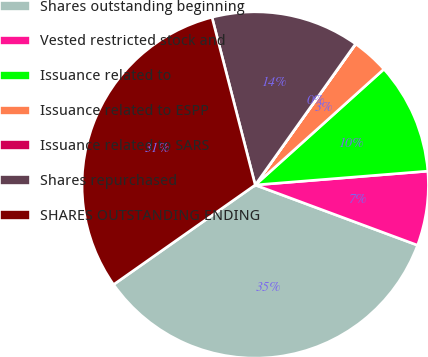Convert chart to OTSL. <chart><loc_0><loc_0><loc_500><loc_500><pie_chart><fcel>Shares outstanding beginning<fcel>Vested restricted stock and<fcel>Issuance related to<fcel>Issuance related to ESPP<fcel>Issuance related to SARS<fcel>Shares repurchased<fcel>SHARES OUTSTANDING ENDING<nl><fcel>34.59%<fcel>6.93%<fcel>10.39%<fcel>3.48%<fcel>0.02%<fcel>13.85%<fcel>30.74%<nl></chart> 